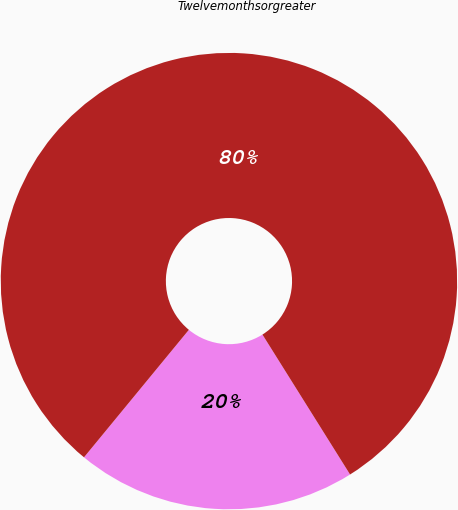Convert chart. <chart><loc_0><loc_0><loc_500><loc_500><pie_chart><ecel><fcel>Twelvemonthsorgreater<nl><fcel>19.86%<fcel>80.14%<nl></chart> 